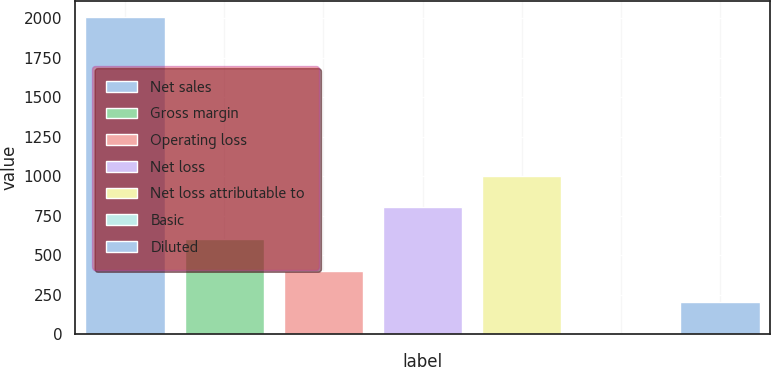Convert chart to OTSL. <chart><loc_0><loc_0><loc_500><loc_500><bar_chart><fcel>Net sales<fcel>Gross margin<fcel>Operating loss<fcel>Net loss<fcel>Net loss attributable to<fcel>Basic<fcel>Diluted<nl><fcel>2009<fcel>602.9<fcel>402.03<fcel>803.77<fcel>1004.64<fcel>0.29<fcel>201.16<nl></chart> 